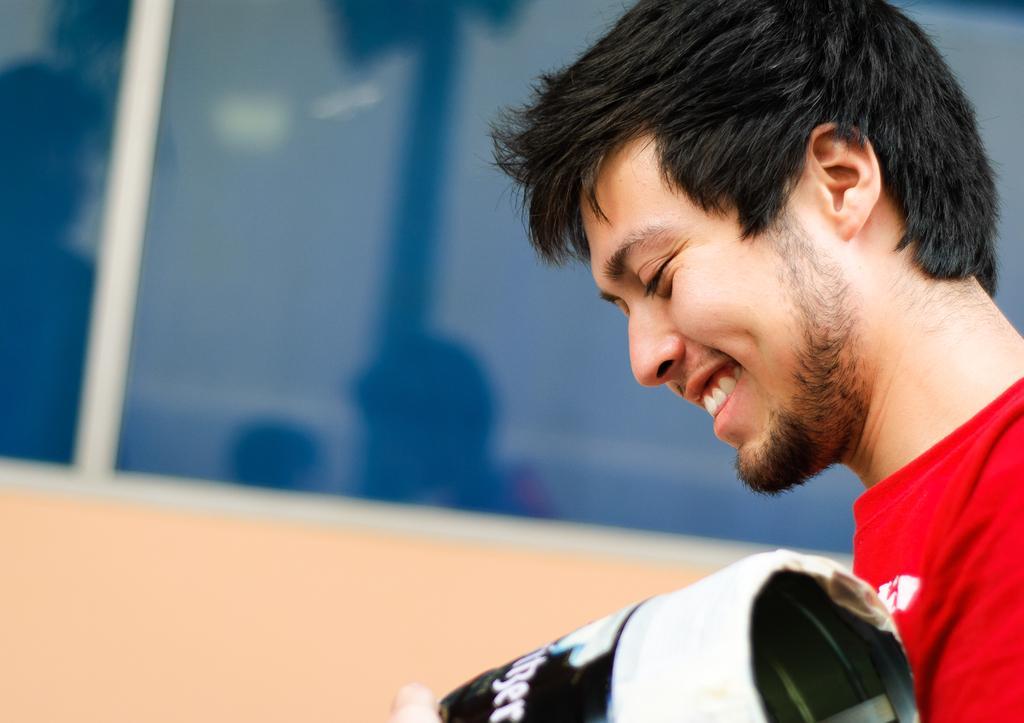Could you give a brief overview of what you see in this image? In this image there is a person holding an object, beside him there is a glass window. 